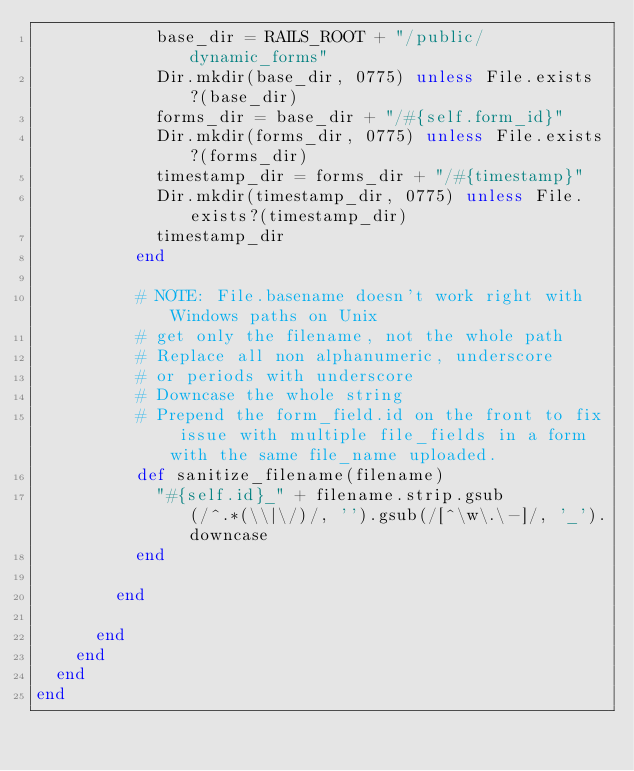<code> <loc_0><loc_0><loc_500><loc_500><_Ruby_>            base_dir = RAILS_ROOT + "/public/dynamic_forms"
            Dir.mkdir(base_dir, 0775) unless File.exists?(base_dir)
            forms_dir = base_dir + "/#{self.form_id}"
            Dir.mkdir(forms_dir, 0775) unless File.exists?(forms_dir)
            timestamp_dir = forms_dir + "/#{timestamp}"
            Dir.mkdir(timestamp_dir, 0775) unless File.exists?(timestamp_dir)
            timestamp_dir
          end
          
          # NOTE: File.basename doesn't work right with Windows paths on Unix
          # get only the filename, not the whole path
          # Replace all non alphanumeric, underscore
          # or periods with underscore
          # Downcase the whole string
          # Prepend the form_field.id on the front to fix issue with multiple file_fields in a form with the same file_name uploaded.
          def sanitize_filename(filename)
            "#{self.id}_" + filename.strip.gsub(/^.*(\\|\/)/, '').gsub(/[^\w\.\-]/, '_').downcase
          end
          
        end
        
      end
    end
  end
end
</code> 